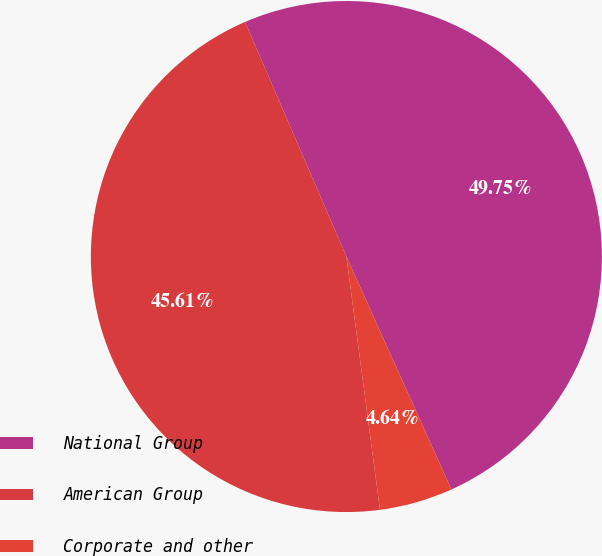Convert chart. <chart><loc_0><loc_0><loc_500><loc_500><pie_chart><fcel>National Group<fcel>American Group<fcel>Corporate and other<nl><fcel>49.75%<fcel>45.61%<fcel>4.64%<nl></chart> 